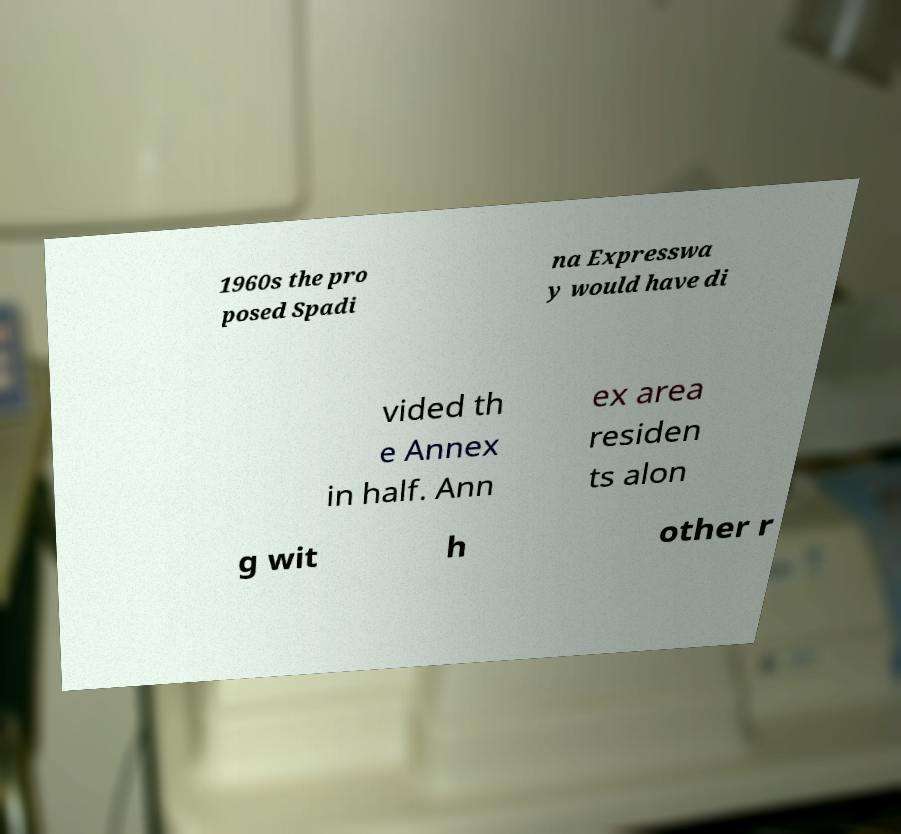There's text embedded in this image that I need extracted. Can you transcribe it verbatim? 1960s the pro posed Spadi na Expresswa y would have di vided th e Annex in half. Ann ex area residen ts alon g wit h other r 